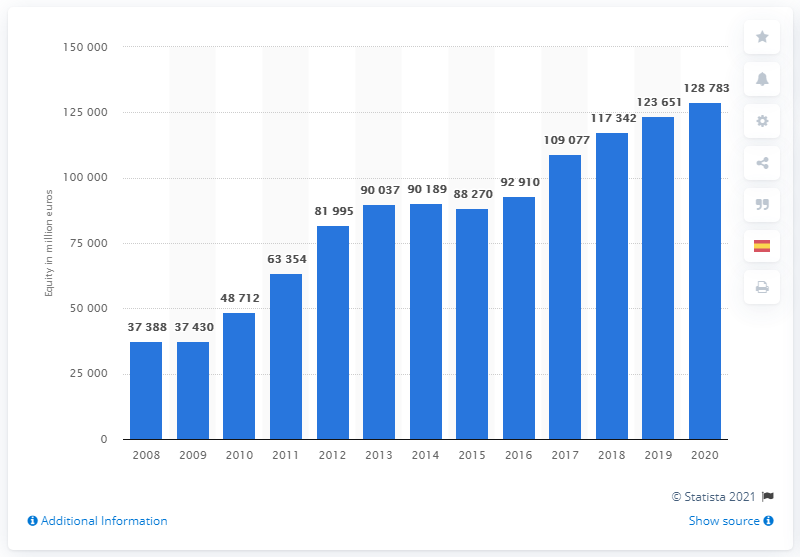List a handful of essential elements in this visual. Volkswagen's equity in 2020 was approximately 128,783. In the year 2020, Volkswagen's equity stood at approximately 129 billion euros. 